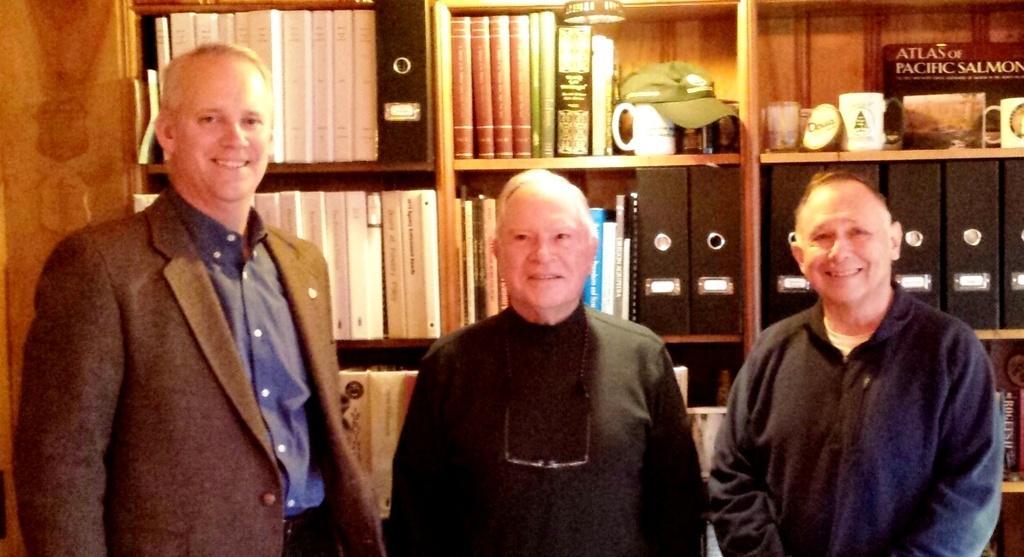Could you give a brief overview of what you see in this image? In this image we can see some persons. In the background of the image there are books, cups, shelves, wooden texture and other objects. 